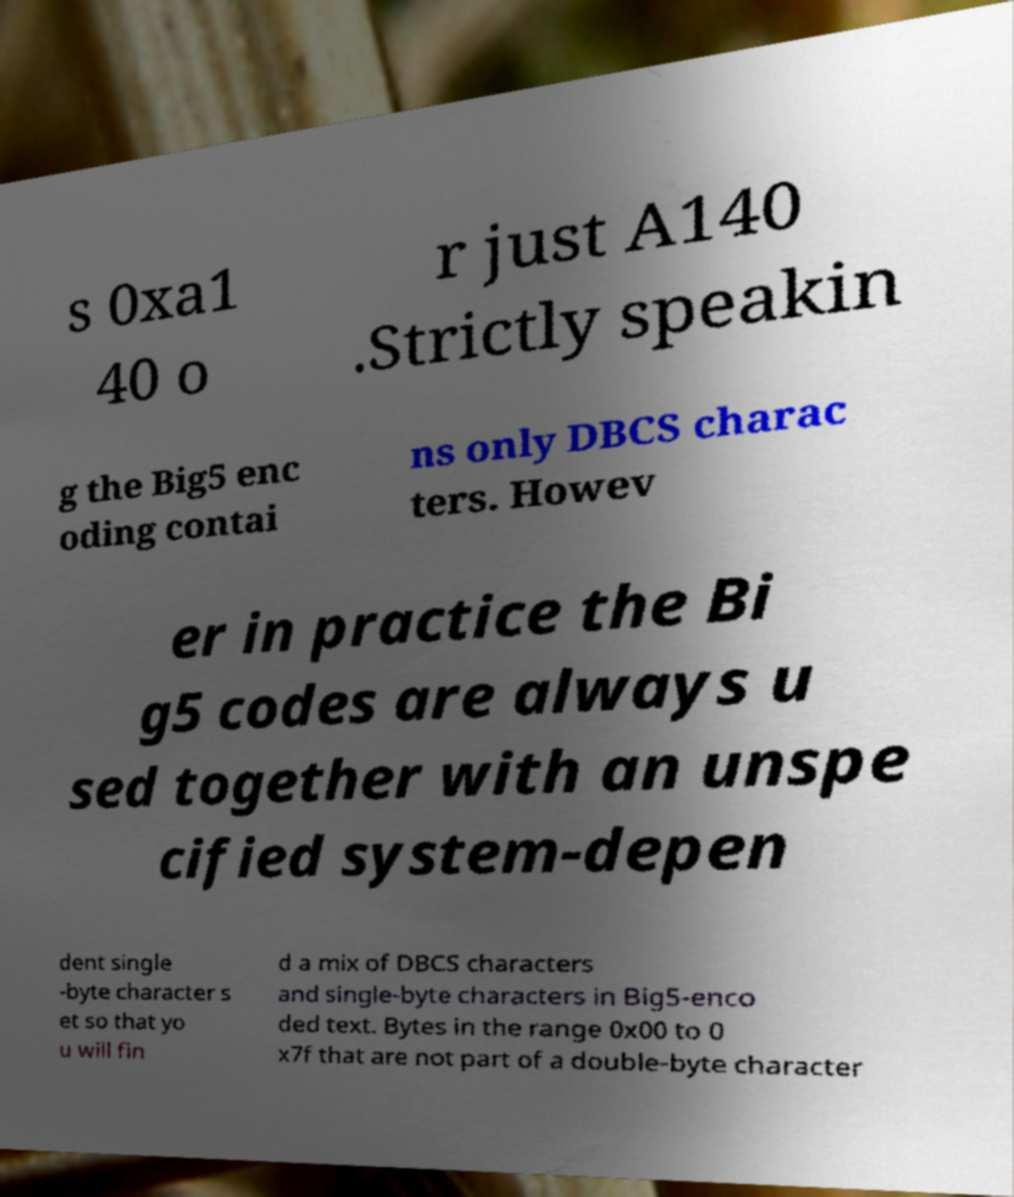Can you accurately transcribe the text from the provided image for me? s 0xa1 40 o r just A140 .Strictly speakin g the Big5 enc oding contai ns only DBCS charac ters. Howev er in practice the Bi g5 codes are always u sed together with an unspe cified system-depen dent single -byte character s et so that yo u will fin d a mix of DBCS characters and single-byte characters in Big5-enco ded text. Bytes in the range 0x00 to 0 x7f that are not part of a double-byte character 